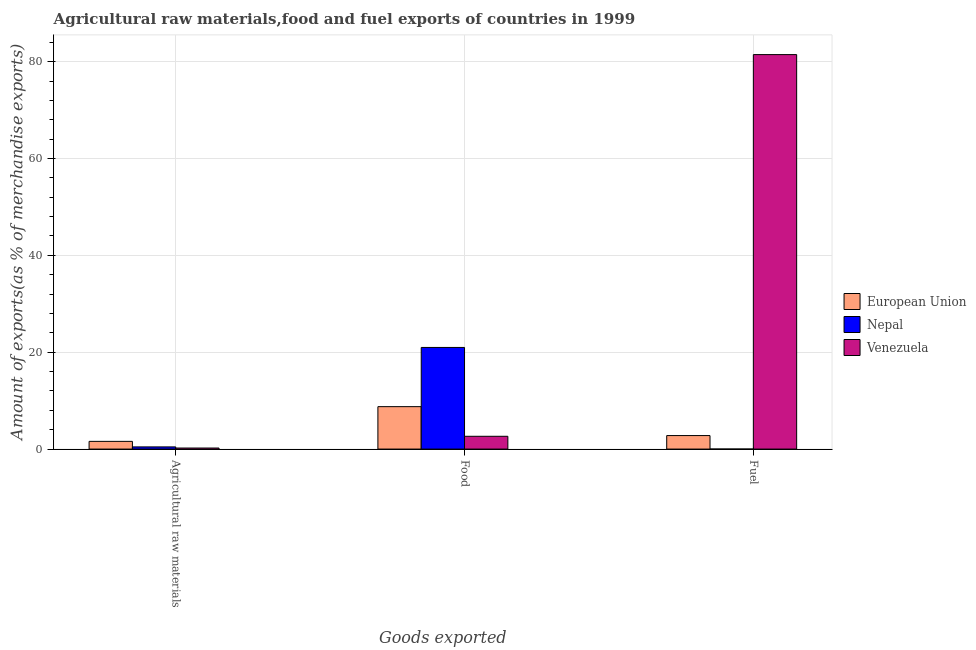How many different coloured bars are there?
Keep it short and to the point. 3. Are the number of bars on each tick of the X-axis equal?
Ensure brevity in your answer.  Yes. What is the label of the 3rd group of bars from the left?
Offer a very short reply. Fuel. What is the percentage of food exports in Nepal?
Ensure brevity in your answer.  20.99. Across all countries, what is the maximum percentage of fuel exports?
Offer a very short reply. 81.45. Across all countries, what is the minimum percentage of fuel exports?
Your response must be concise. 0. In which country was the percentage of raw materials exports maximum?
Offer a very short reply. European Union. In which country was the percentage of raw materials exports minimum?
Your response must be concise. Venezuela. What is the total percentage of food exports in the graph?
Your answer should be very brief. 32.39. What is the difference between the percentage of fuel exports in Venezuela and that in European Union?
Your answer should be very brief. 78.67. What is the difference between the percentage of food exports in European Union and the percentage of raw materials exports in Nepal?
Your answer should be compact. 8.31. What is the average percentage of fuel exports per country?
Ensure brevity in your answer.  28.08. What is the difference between the percentage of raw materials exports and percentage of fuel exports in European Union?
Provide a succinct answer. -1.2. In how many countries, is the percentage of fuel exports greater than 44 %?
Provide a succinct answer. 1. What is the ratio of the percentage of raw materials exports in Nepal to that in European Union?
Your answer should be very brief. 0.28. Is the difference between the percentage of food exports in Nepal and Venezuela greater than the difference between the percentage of fuel exports in Nepal and Venezuela?
Your answer should be very brief. Yes. What is the difference between the highest and the second highest percentage of fuel exports?
Offer a very short reply. 78.67. What is the difference between the highest and the lowest percentage of raw materials exports?
Give a very brief answer. 1.37. In how many countries, is the percentage of raw materials exports greater than the average percentage of raw materials exports taken over all countries?
Offer a terse response. 1. Is the sum of the percentage of food exports in European Union and Nepal greater than the maximum percentage of fuel exports across all countries?
Keep it short and to the point. No. What does the 2nd bar from the left in Agricultural raw materials represents?
Offer a terse response. Nepal. What does the 2nd bar from the right in Fuel represents?
Give a very brief answer. Nepal. Is it the case that in every country, the sum of the percentage of raw materials exports and percentage of food exports is greater than the percentage of fuel exports?
Give a very brief answer. No. Are all the bars in the graph horizontal?
Ensure brevity in your answer.  No. How many countries are there in the graph?
Offer a very short reply. 3. What is the difference between two consecutive major ticks on the Y-axis?
Offer a very short reply. 20. Are the values on the major ticks of Y-axis written in scientific E-notation?
Give a very brief answer. No. Does the graph contain any zero values?
Your answer should be compact. No. Does the graph contain grids?
Your answer should be very brief. Yes. What is the title of the graph?
Your answer should be very brief. Agricultural raw materials,food and fuel exports of countries in 1999. What is the label or title of the X-axis?
Give a very brief answer. Goods exported. What is the label or title of the Y-axis?
Provide a succinct answer. Amount of exports(as % of merchandise exports). What is the Amount of exports(as % of merchandise exports) in European Union in Agricultural raw materials?
Provide a succinct answer. 1.59. What is the Amount of exports(as % of merchandise exports) of Nepal in Agricultural raw materials?
Provide a short and direct response. 0.45. What is the Amount of exports(as % of merchandise exports) in Venezuela in Agricultural raw materials?
Give a very brief answer. 0.22. What is the Amount of exports(as % of merchandise exports) of European Union in Food?
Keep it short and to the point. 8.76. What is the Amount of exports(as % of merchandise exports) of Nepal in Food?
Your answer should be very brief. 20.99. What is the Amount of exports(as % of merchandise exports) in Venezuela in Food?
Your answer should be compact. 2.64. What is the Amount of exports(as % of merchandise exports) in European Union in Fuel?
Your answer should be very brief. 2.79. What is the Amount of exports(as % of merchandise exports) of Nepal in Fuel?
Your answer should be very brief. 0. What is the Amount of exports(as % of merchandise exports) in Venezuela in Fuel?
Your response must be concise. 81.45. Across all Goods exported, what is the maximum Amount of exports(as % of merchandise exports) in European Union?
Keep it short and to the point. 8.76. Across all Goods exported, what is the maximum Amount of exports(as % of merchandise exports) of Nepal?
Your response must be concise. 20.99. Across all Goods exported, what is the maximum Amount of exports(as % of merchandise exports) of Venezuela?
Offer a terse response. 81.45. Across all Goods exported, what is the minimum Amount of exports(as % of merchandise exports) in European Union?
Your answer should be compact. 1.59. Across all Goods exported, what is the minimum Amount of exports(as % of merchandise exports) of Nepal?
Your answer should be compact. 0. Across all Goods exported, what is the minimum Amount of exports(as % of merchandise exports) in Venezuela?
Offer a terse response. 0.22. What is the total Amount of exports(as % of merchandise exports) of European Union in the graph?
Your answer should be compact. 13.14. What is the total Amount of exports(as % of merchandise exports) of Nepal in the graph?
Give a very brief answer. 21.44. What is the total Amount of exports(as % of merchandise exports) in Venezuela in the graph?
Provide a short and direct response. 84.31. What is the difference between the Amount of exports(as % of merchandise exports) of European Union in Agricultural raw materials and that in Food?
Offer a very short reply. -7.17. What is the difference between the Amount of exports(as % of merchandise exports) of Nepal in Agricultural raw materials and that in Food?
Provide a short and direct response. -20.54. What is the difference between the Amount of exports(as % of merchandise exports) in Venezuela in Agricultural raw materials and that in Food?
Give a very brief answer. -2.42. What is the difference between the Amount of exports(as % of merchandise exports) of European Union in Agricultural raw materials and that in Fuel?
Give a very brief answer. -1.2. What is the difference between the Amount of exports(as % of merchandise exports) of Nepal in Agricultural raw materials and that in Fuel?
Your response must be concise. 0.45. What is the difference between the Amount of exports(as % of merchandise exports) of Venezuela in Agricultural raw materials and that in Fuel?
Offer a terse response. -81.24. What is the difference between the Amount of exports(as % of merchandise exports) of European Union in Food and that in Fuel?
Provide a succinct answer. 5.97. What is the difference between the Amount of exports(as % of merchandise exports) of Nepal in Food and that in Fuel?
Make the answer very short. 20.98. What is the difference between the Amount of exports(as % of merchandise exports) in Venezuela in Food and that in Fuel?
Give a very brief answer. -78.81. What is the difference between the Amount of exports(as % of merchandise exports) in European Union in Agricultural raw materials and the Amount of exports(as % of merchandise exports) in Nepal in Food?
Make the answer very short. -19.39. What is the difference between the Amount of exports(as % of merchandise exports) in European Union in Agricultural raw materials and the Amount of exports(as % of merchandise exports) in Venezuela in Food?
Your answer should be very brief. -1.05. What is the difference between the Amount of exports(as % of merchandise exports) of Nepal in Agricultural raw materials and the Amount of exports(as % of merchandise exports) of Venezuela in Food?
Keep it short and to the point. -2.19. What is the difference between the Amount of exports(as % of merchandise exports) in European Union in Agricultural raw materials and the Amount of exports(as % of merchandise exports) in Nepal in Fuel?
Keep it short and to the point. 1.59. What is the difference between the Amount of exports(as % of merchandise exports) in European Union in Agricultural raw materials and the Amount of exports(as % of merchandise exports) in Venezuela in Fuel?
Provide a short and direct response. -79.86. What is the difference between the Amount of exports(as % of merchandise exports) in Nepal in Agricultural raw materials and the Amount of exports(as % of merchandise exports) in Venezuela in Fuel?
Keep it short and to the point. -81. What is the difference between the Amount of exports(as % of merchandise exports) in European Union in Food and the Amount of exports(as % of merchandise exports) in Nepal in Fuel?
Your answer should be very brief. 8.76. What is the difference between the Amount of exports(as % of merchandise exports) of European Union in Food and the Amount of exports(as % of merchandise exports) of Venezuela in Fuel?
Ensure brevity in your answer.  -72.69. What is the difference between the Amount of exports(as % of merchandise exports) of Nepal in Food and the Amount of exports(as % of merchandise exports) of Venezuela in Fuel?
Make the answer very short. -60.47. What is the average Amount of exports(as % of merchandise exports) of European Union per Goods exported?
Your answer should be very brief. 4.38. What is the average Amount of exports(as % of merchandise exports) of Nepal per Goods exported?
Ensure brevity in your answer.  7.15. What is the average Amount of exports(as % of merchandise exports) in Venezuela per Goods exported?
Offer a very short reply. 28.1. What is the difference between the Amount of exports(as % of merchandise exports) in European Union and Amount of exports(as % of merchandise exports) in Nepal in Agricultural raw materials?
Provide a short and direct response. 1.14. What is the difference between the Amount of exports(as % of merchandise exports) in European Union and Amount of exports(as % of merchandise exports) in Venezuela in Agricultural raw materials?
Give a very brief answer. 1.37. What is the difference between the Amount of exports(as % of merchandise exports) of Nepal and Amount of exports(as % of merchandise exports) of Venezuela in Agricultural raw materials?
Your answer should be compact. 0.23. What is the difference between the Amount of exports(as % of merchandise exports) in European Union and Amount of exports(as % of merchandise exports) in Nepal in Food?
Provide a short and direct response. -12.23. What is the difference between the Amount of exports(as % of merchandise exports) in European Union and Amount of exports(as % of merchandise exports) in Venezuela in Food?
Offer a very short reply. 6.12. What is the difference between the Amount of exports(as % of merchandise exports) of Nepal and Amount of exports(as % of merchandise exports) of Venezuela in Food?
Offer a terse response. 18.35. What is the difference between the Amount of exports(as % of merchandise exports) of European Union and Amount of exports(as % of merchandise exports) of Nepal in Fuel?
Your response must be concise. 2.79. What is the difference between the Amount of exports(as % of merchandise exports) in European Union and Amount of exports(as % of merchandise exports) in Venezuela in Fuel?
Your answer should be very brief. -78.67. What is the difference between the Amount of exports(as % of merchandise exports) of Nepal and Amount of exports(as % of merchandise exports) of Venezuela in Fuel?
Make the answer very short. -81.45. What is the ratio of the Amount of exports(as % of merchandise exports) of European Union in Agricultural raw materials to that in Food?
Provide a short and direct response. 0.18. What is the ratio of the Amount of exports(as % of merchandise exports) in Nepal in Agricultural raw materials to that in Food?
Offer a terse response. 0.02. What is the ratio of the Amount of exports(as % of merchandise exports) in Venezuela in Agricultural raw materials to that in Food?
Make the answer very short. 0.08. What is the ratio of the Amount of exports(as % of merchandise exports) of European Union in Agricultural raw materials to that in Fuel?
Make the answer very short. 0.57. What is the ratio of the Amount of exports(as % of merchandise exports) in Nepal in Agricultural raw materials to that in Fuel?
Keep it short and to the point. 208.31. What is the ratio of the Amount of exports(as % of merchandise exports) in Venezuela in Agricultural raw materials to that in Fuel?
Your answer should be compact. 0. What is the ratio of the Amount of exports(as % of merchandise exports) in European Union in Food to that in Fuel?
Provide a succinct answer. 3.14. What is the ratio of the Amount of exports(as % of merchandise exports) in Nepal in Food to that in Fuel?
Offer a terse response. 9706.4. What is the ratio of the Amount of exports(as % of merchandise exports) in Venezuela in Food to that in Fuel?
Your answer should be very brief. 0.03. What is the difference between the highest and the second highest Amount of exports(as % of merchandise exports) in European Union?
Ensure brevity in your answer.  5.97. What is the difference between the highest and the second highest Amount of exports(as % of merchandise exports) in Nepal?
Your response must be concise. 20.54. What is the difference between the highest and the second highest Amount of exports(as % of merchandise exports) of Venezuela?
Offer a very short reply. 78.81. What is the difference between the highest and the lowest Amount of exports(as % of merchandise exports) in European Union?
Your answer should be very brief. 7.17. What is the difference between the highest and the lowest Amount of exports(as % of merchandise exports) in Nepal?
Offer a terse response. 20.98. What is the difference between the highest and the lowest Amount of exports(as % of merchandise exports) in Venezuela?
Your answer should be compact. 81.24. 